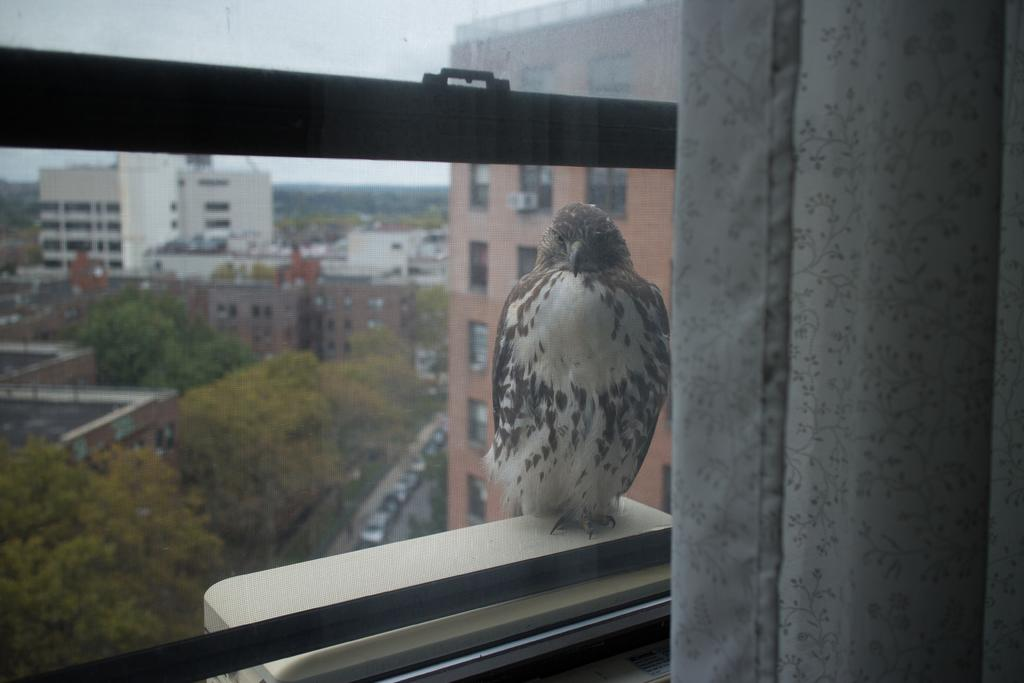What type of animal can be seen in the image? There is a bird in the image. Where is the bird located in the image? The bird is standing on a window wall. What can be seen in the background of the image? There are buildings, trees, and the sky visible in the background of the image. What type of behavior does the owl exhibit in the image? There is no owl present in the image; it features a bird. How many birds are visible in the image? The image only shows one bird, so the amount is not plural. 